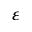<formula> <loc_0><loc_0><loc_500><loc_500>\varepsilon</formula> 